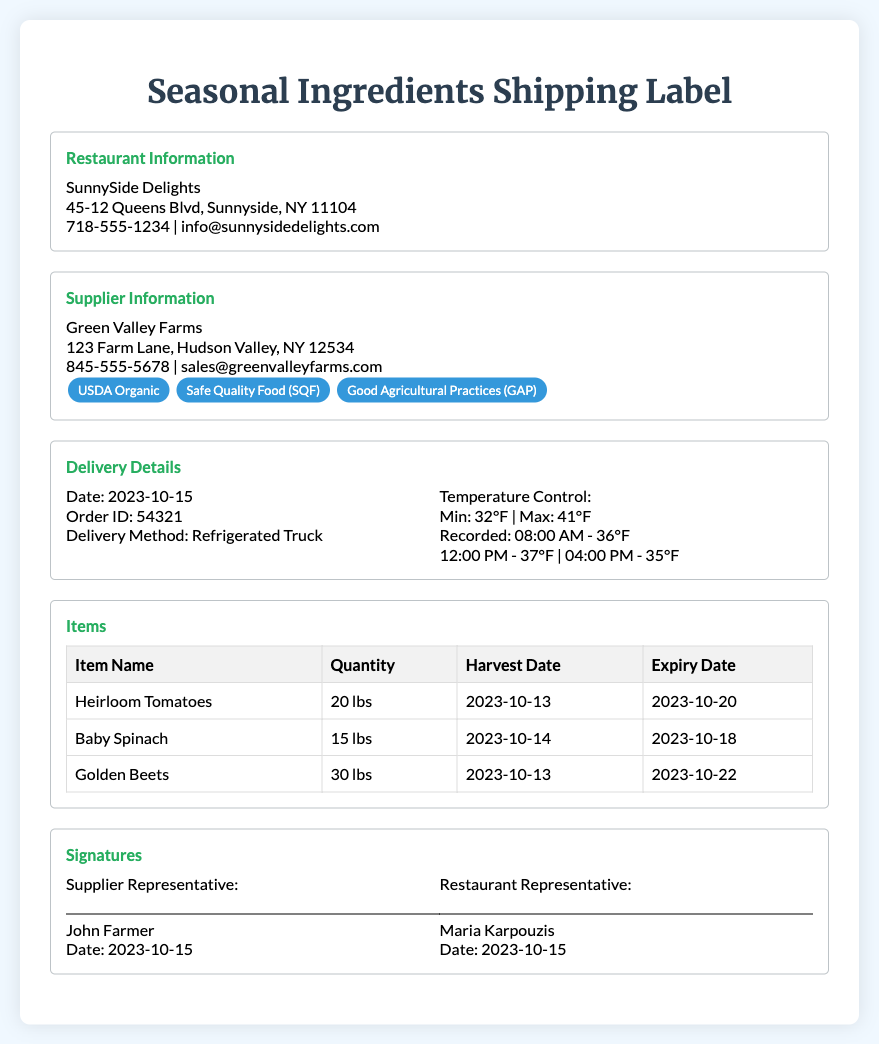What is the name of the restaurant? The restaurant name is provided in the document's header under "Restaurant Information."
Answer: SunnySide Delights Who is the supplier of the ingredients? The supplier's name is located in the "Supplier Information" section of the document.
Answer: Green Valley Farms What is the delivery date? The delivery date can be found in the "Delivery Details" section of the document.
Answer: 2023-10-15 What is the recorded temperature at 12:00 PM? The recorded temperatures during delivery include the time and temperature data.
Answer: 37°F How many pounds of Baby Spinach were ordered? The quantity can be found in the "Items" table corresponding to Baby Spinach.
Answer: 15 lbs Which certification is NOT included for the supplier? The certifications are listed within the "Supplier Information" section; identifying the missing ones requires comparison with common certifications.
Answer: None (All shown are included) What is the maximum temperature control allowed? The maximum temperature is stated in the "Temperature Control" subsection of "Delivery Details."
Answer: 41°F Who is the restaurant representative? The name of the restaurant representative is included in the "Signatures" section.
Answer: Maria Karpouzis How many items were listed on the shipping label? The number of items can be counted in the "Items" table.
Answer: 3 